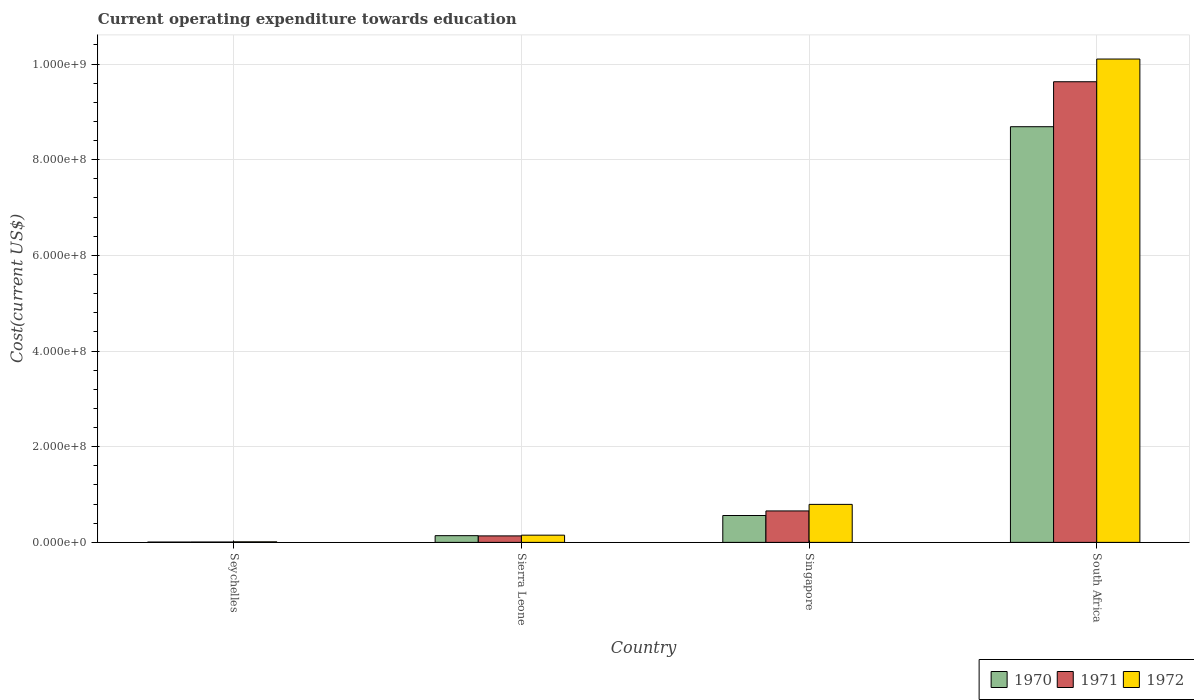How many groups of bars are there?
Keep it short and to the point. 4. Are the number of bars on each tick of the X-axis equal?
Your answer should be compact. Yes. How many bars are there on the 4th tick from the right?
Your answer should be compact. 3. What is the label of the 4th group of bars from the left?
Offer a very short reply. South Africa. In how many cases, is the number of bars for a given country not equal to the number of legend labels?
Ensure brevity in your answer.  0. What is the expenditure towards education in 1970 in Singapore?
Give a very brief answer. 5.62e+07. Across all countries, what is the maximum expenditure towards education in 1972?
Give a very brief answer. 1.01e+09. Across all countries, what is the minimum expenditure towards education in 1971?
Your answer should be compact. 7.88e+05. In which country was the expenditure towards education in 1972 maximum?
Your answer should be very brief. South Africa. In which country was the expenditure towards education in 1971 minimum?
Keep it short and to the point. Seychelles. What is the total expenditure towards education in 1971 in the graph?
Provide a short and direct response. 1.04e+09. What is the difference between the expenditure towards education in 1970 in Seychelles and that in South Africa?
Your response must be concise. -8.68e+08. What is the difference between the expenditure towards education in 1972 in Sierra Leone and the expenditure towards education in 1971 in Seychelles?
Give a very brief answer. 1.43e+07. What is the average expenditure towards education in 1971 per country?
Provide a succinct answer. 2.61e+08. What is the difference between the expenditure towards education of/in 1972 and expenditure towards education of/in 1970 in South Africa?
Provide a succinct answer. 1.41e+08. What is the ratio of the expenditure towards education in 1970 in Sierra Leone to that in South Africa?
Your answer should be compact. 0.02. Is the difference between the expenditure towards education in 1972 in Seychelles and South Africa greater than the difference between the expenditure towards education in 1970 in Seychelles and South Africa?
Offer a terse response. No. What is the difference between the highest and the second highest expenditure towards education in 1970?
Ensure brevity in your answer.  8.13e+08. What is the difference between the highest and the lowest expenditure towards education in 1972?
Offer a terse response. 1.01e+09. What does the 2nd bar from the left in Singapore represents?
Your response must be concise. 1971. Is it the case that in every country, the sum of the expenditure towards education in 1970 and expenditure towards education in 1971 is greater than the expenditure towards education in 1972?
Offer a terse response. Yes. How many bars are there?
Keep it short and to the point. 12. Are all the bars in the graph horizontal?
Ensure brevity in your answer.  No. How many countries are there in the graph?
Make the answer very short. 4. What is the difference between two consecutive major ticks on the Y-axis?
Your response must be concise. 2.00e+08. Are the values on the major ticks of Y-axis written in scientific E-notation?
Ensure brevity in your answer.  Yes. Does the graph contain any zero values?
Your response must be concise. No. Does the graph contain grids?
Keep it short and to the point. Yes. How many legend labels are there?
Offer a terse response. 3. What is the title of the graph?
Provide a succinct answer. Current operating expenditure towards education. Does "1962" appear as one of the legend labels in the graph?
Make the answer very short. No. What is the label or title of the Y-axis?
Keep it short and to the point. Cost(current US$). What is the Cost(current US$) of 1970 in Seychelles?
Provide a short and direct response. 6.98e+05. What is the Cost(current US$) of 1971 in Seychelles?
Offer a terse response. 7.88e+05. What is the Cost(current US$) of 1972 in Seychelles?
Make the answer very short. 1.19e+06. What is the Cost(current US$) in 1970 in Sierra Leone?
Your answer should be very brief. 1.40e+07. What is the Cost(current US$) in 1971 in Sierra Leone?
Give a very brief answer. 1.36e+07. What is the Cost(current US$) in 1972 in Sierra Leone?
Keep it short and to the point. 1.51e+07. What is the Cost(current US$) of 1970 in Singapore?
Keep it short and to the point. 5.62e+07. What is the Cost(current US$) in 1971 in Singapore?
Offer a very short reply. 6.57e+07. What is the Cost(current US$) in 1972 in Singapore?
Provide a succinct answer. 7.95e+07. What is the Cost(current US$) of 1970 in South Africa?
Ensure brevity in your answer.  8.69e+08. What is the Cost(current US$) in 1971 in South Africa?
Your answer should be very brief. 9.63e+08. What is the Cost(current US$) in 1972 in South Africa?
Offer a terse response. 1.01e+09. Across all countries, what is the maximum Cost(current US$) in 1970?
Give a very brief answer. 8.69e+08. Across all countries, what is the maximum Cost(current US$) of 1971?
Your answer should be compact. 9.63e+08. Across all countries, what is the maximum Cost(current US$) in 1972?
Offer a terse response. 1.01e+09. Across all countries, what is the minimum Cost(current US$) of 1970?
Your answer should be compact. 6.98e+05. Across all countries, what is the minimum Cost(current US$) in 1971?
Give a very brief answer. 7.88e+05. Across all countries, what is the minimum Cost(current US$) of 1972?
Offer a very short reply. 1.19e+06. What is the total Cost(current US$) in 1970 in the graph?
Your answer should be compact. 9.40e+08. What is the total Cost(current US$) in 1971 in the graph?
Give a very brief answer. 1.04e+09. What is the total Cost(current US$) in 1972 in the graph?
Provide a succinct answer. 1.11e+09. What is the difference between the Cost(current US$) of 1970 in Seychelles and that in Sierra Leone?
Provide a succinct answer. -1.33e+07. What is the difference between the Cost(current US$) in 1971 in Seychelles and that in Sierra Leone?
Provide a succinct answer. -1.28e+07. What is the difference between the Cost(current US$) in 1972 in Seychelles and that in Sierra Leone?
Ensure brevity in your answer.  -1.39e+07. What is the difference between the Cost(current US$) of 1970 in Seychelles and that in Singapore?
Give a very brief answer. -5.55e+07. What is the difference between the Cost(current US$) of 1971 in Seychelles and that in Singapore?
Your response must be concise. -6.50e+07. What is the difference between the Cost(current US$) of 1972 in Seychelles and that in Singapore?
Offer a very short reply. -7.83e+07. What is the difference between the Cost(current US$) in 1970 in Seychelles and that in South Africa?
Provide a succinct answer. -8.68e+08. What is the difference between the Cost(current US$) of 1971 in Seychelles and that in South Africa?
Keep it short and to the point. -9.62e+08. What is the difference between the Cost(current US$) of 1972 in Seychelles and that in South Africa?
Ensure brevity in your answer.  -1.01e+09. What is the difference between the Cost(current US$) of 1970 in Sierra Leone and that in Singapore?
Ensure brevity in your answer.  -4.22e+07. What is the difference between the Cost(current US$) in 1971 in Sierra Leone and that in Singapore?
Your answer should be compact. -5.22e+07. What is the difference between the Cost(current US$) of 1972 in Sierra Leone and that in Singapore?
Offer a very short reply. -6.44e+07. What is the difference between the Cost(current US$) of 1970 in Sierra Leone and that in South Africa?
Make the answer very short. -8.55e+08. What is the difference between the Cost(current US$) of 1971 in Sierra Leone and that in South Africa?
Provide a short and direct response. -9.50e+08. What is the difference between the Cost(current US$) in 1972 in Sierra Leone and that in South Africa?
Provide a short and direct response. -9.95e+08. What is the difference between the Cost(current US$) of 1970 in Singapore and that in South Africa?
Ensure brevity in your answer.  -8.13e+08. What is the difference between the Cost(current US$) in 1971 in Singapore and that in South Africa?
Ensure brevity in your answer.  -8.97e+08. What is the difference between the Cost(current US$) of 1972 in Singapore and that in South Africa?
Provide a short and direct response. -9.31e+08. What is the difference between the Cost(current US$) of 1970 in Seychelles and the Cost(current US$) of 1971 in Sierra Leone?
Your response must be concise. -1.29e+07. What is the difference between the Cost(current US$) of 1970 in Seychelles and the Cost(current US$) of 1972 in Sierra Leone?
Give a very brief answer. -1.44e+07. What is the difference between the Cost(current US$) of 1971 in Seychelles and the Cost(current US$) of 1972 in Sierra Leone?
Provide a succinct answer. -1.43e+07. What is the difference between the Cost(current US$) in 1970 in Seychelles and the Cost(current US$) in 1971 in Singapore?
Ensure brevity in your answer.  -6.50e+07. What is the difference between the Cost(current US$) in 1970 in Seychelles and the Cost(current US$) in 1972 in Singapore?
Your response must be concise. -7.88e+07. What is the difference between the Cost(current US$) of 1971 in Seychelles and the Cost(current US$) of 1972 in Singapore?
Provide a succinct answer. -7.87e+07. What is the difference between the Cost(current US$) in 1970 in Seychelles and the Cost(current US$) in 1971 in South Africa?
Ensure brevity in your answer.  -9.62e+08. What is the difference between the Cost(current US$) in 1970 in Seychelles and the Cost(current US$) in 1972 in South Africa?
Keep it short and to the point. -1.01e+09. What is the difference between the Cost(current US$) in 1971 in Seychelles and the Cost(current US$) in 1972 in South Africa?
Provide a succinct answer. -1.01e+09. What is the difference between the Cost(current US$) in 1970 in Sierra Leone and the Cost(current US$) in 1971 in Singapore?
Provide a succinct answer. -5.17e+07. What is the difference between the Cost(current US$) in 1970 in Sierra Leone and the Cost(current US$) in 1972 in Singapore?
Offer a very short reply. -6.54e+07. What is the difference between the Cost(current US$) of 1971 in Sierra Leone and the Cost(current US$) of 1972 in Singapore?
Keep it short and to the point. -6.59e+07. What is the difference between the Cost(current US$) in 1970 in Sierra Leone and the Cost(current US$) in 1971 in South Africa?
Your answer should be very brief. -9.49e+08. What is the difference between the Cost(current US$) of 1970 in Sierra Leone and the Cost(current US$) of 1972 in South Africa?
Offer a very short reply. -9.96e+08. What is the difference between the Cost(current US$) of 1971 in Sierra Leone and the Cost(current US$) of 1972 in South Africa?
Keep it short and to the point. -9.97e+08. What is the difference between the Cost(current US$) in 1970 in Singapore and the Cost(current US$) in 1971 in South Africa?
Your answer should be compact. -9.07e+08. What is the difference between the Cost(current US$) of 1970 in Singapore and the Cost(current US$) of 1972 in South Africa?
Provide a short and direct response. -9.54e+08. What is the difference between the Cost(current US$) in 1971 in Singapore and the Cost(current US$) in 1972 in South Africa?
Your answer should be compact. -9.45e+08. What is the average Cost(current US$) of 1970 per country?
Your answer should be very brief. 2.35e+08. What is the average Cost(current US$) in 1971 per country?
Your answer should be compact. 2.61e+08. What is the average Cost(current US$) of 1972 per country?
Ensure brevity in your answer.  2.77e+08. What is the difference between the Cost(current US$) in 1970 and Cost(current US$) in 1971 in Seychelles?
Ensure brevity in your answer.  -8.98e+04. What is the difference between the Cost(current US$) in 1970 and Cost(current US$) in 1972 in Seychelles?
Offer a very short reply. -4.93e+05. What is the difference between the Cost(current US$) of 1971 and Cost(current US$) of 1972 in Seychelles?
Your answer should be compact. -4.03e+05. What is the difference between the Cost(current US$) of 1970 and Cost(current US$) of 1971 in Sierra Leone?
Provide a short and direct response. 4.96e+05. What is the difference between the Cost(current US$) in 1970 and Cost(current US$) in 1972 in Sierra Leone?
Give a very brief answer. -1.05e+06. What is the difference between the Cost(current US$) in 1971 and Cost(current US$) in 1972 in Sierra Leone?
Your answer should be very brief. -1.55e+06. What is the difference between the Cost(current US$) in 1970 and Cost(current US$) in 1971 in Singapore?
Provide a succinct answer. -9.55e+06. What is the difference between the Cost(current US$) in 1970 and Cost(current US$) in 1972 in Singapore?
Keep it short and to the point. -2.33e+07. What is the difference between the Cost(current US$) of 1971 and Cost(current US$) of 1972 in Singapore?
Offer a terse response. -1.37e+07. What is the difference between the Cost(current US$) in 1970 and Cost(current US$) in 1971 in South Africa?
Provide a succinct answer. -9.40e+07. What is the difference between the Cost(current US$) of 1970 and Cost(current US$) of 1972 in South Africa?
Give a very brief answer. -1.41e+08. What is the difference between the Cost(current US$) of 1971 and Cost(current US$) of 1972 in South Africa?
Make the answer very short. -4.74e+07. What is the ratio of the Cost(current US$) of 1970 in Seychelles to that in Sierra Leone?
Make the answer very short. 0.05. What is the ratio of the Cost(current US$) of 1971 in Seychelles to that in Sierra Leone?
Provide a short and direct response. 0.06. What is the ratio of the Cost(current US$) in 1972 in Seychelles to that in Sierra Leone?
Offer a very short reply. 0.08. What is the ratio of the Cost(current US$) of 1970 in Seychelles to that in Singapore?
Offer a terse response. 0.01. What is the ratio of the Cost(current US$) in 1971 in Seychelles to that in Singapore?
Your answer should be very brief. 0.01. What is the ratio of the Cost(current US$) in 1972 in Seychelles to that in Singapore?
Keep it short and to the point. 0.01. What is the ratio of the Cost(current US$) of 1970 in Seychelles to that in South Africa?
Your answer should be very brief. 0. What is the ratio of the Cost(current US$) in 1971 in Seychelles to that in South Africa?
Ensure brevity in your answer.  0. What is the ratio of the Cost(current US$) in 1972 in Seychelles to that in South Africa?
Your answer should be compact. 0. What is the ratio of the Cost(current US$) in 1970 in Sierra Leone to that in Singapore?
Keep it short and to the point. 0.25. What is the ratio of the Cost(current US$) in 1971 in Sierra Leone to that in Singapore?
Make the answer very short. 0.21. What is the ratio of the Cost(current US$) of 1972 in Sierra Leone to that in Singapore?
Offer a very short reply. 0.19. What is the ratio of the Cost(current US$) of 1970 in Sierra Leone to that in South Africa?
Make the answer very short. 0.02. What is the ratio of the Cost(current US$) of 1971 in Sierra Leone to that in South Africa?
Your response must be concise. 0.01. What is the ratio of the Cost(current US$) of 1972 in Sierra Leone to that in South Africa?
Offer a very short reply. 0.01. What is the ratio of the Cost(current US$) in 1970 in Singapore to that in South Africa?
Make the answer very short. 0.06. What is the ratio of the Cost(current US$) of 1971 in Singapore to that in South Africa?
Your answer should be very brief. 0.07. What is the ratio of the Cost(current US$) of 1972 in Singapore to that in South Africa?
Provide a short and direct response. 0.08. What is the difference between the highest and the second highest Cost(current US$) of 1970?
Offer a very short reply. 8.13e+08. What is the difference between the highest and the second highest Cost(current US$) of 1971?
Your answer should be compact. 8.97e+08. What is the difference between the highest and the second highest Cost(current US$) in 1972?
Give a very brief answer. 9.31e+08. What is the difference between the highest and the lowest Cost(current US$) of 1970?
Your answer should be compact. 8.68e+08. What is the difference between the highest and the lowest Cost(current US$) in 1971?
Provide a succinct answer. 9.62e+08. What is the difference between the highest and the lowest Cost(current US$) in 1972?
Offer a terse response. 1.01e+09. 